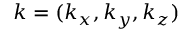<formula> <loc_0><loc_0><loc_500><loc_500>k = ( k _ { x } , k _ { y } , k _ { z } )</formula> 